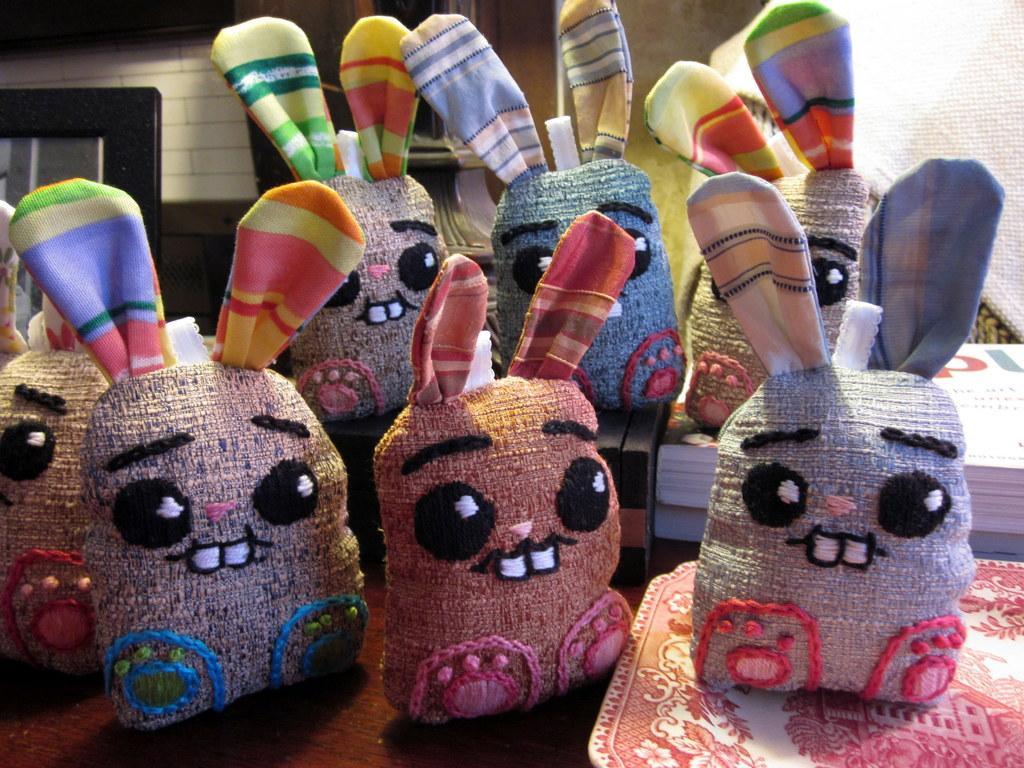Describe this image in one or two sentences. As we can see in the image there are white color tiles, door, bags and tables. 